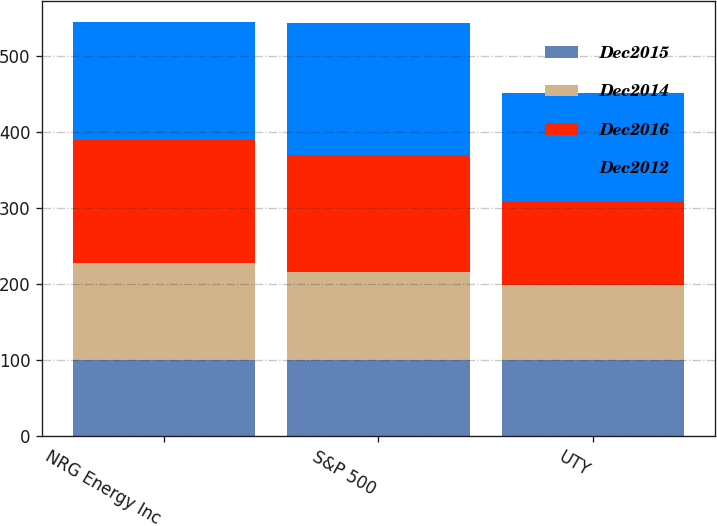Convert chart. <chart><loc_0><loc_0><loc_500><loc_500><stacked_bar_chart><ecel><fcel>NRG Energy Inc<fcel>S&P 500<fcel>UTY<nl><fcel>Dec2015<fcel>100<fcel>100<fcel>100<nl><fcel>Dec2014<fcel>127.98<fcel>116<fcel>99.44<nl><fcel>Dec2016<fcel>162.56<fcel>153.57<fcel>110.35<nl><fcel>Dec2012<fcel>155.29<fcel>174.6<fcel>142.29<nl></chart> 